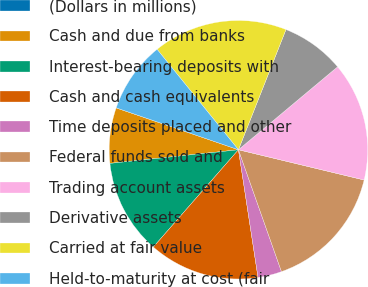Convert chart to OTSL. <chart><loc_0><loc_0><loc_500><loc_500><pie_chart><fcel>(Dollars in millions)<fcel>Cash and due from banks<fcel>Interest-bearing deposits with<fcel>Cash and cash equivalents<fcel>Time deposits placed and other<fcel>Federal funds sold and<fcel>Trading account assets<fcel>Derivative assets<fcel>Carried at fair value<fcel>Held-to-maturity at cost (fair<nl><fcel>0.01%<fcel>6.93%<fcel>11.88%<fcel>13.86%<fcel>2.98%<fcel>15.84%<fcel>14.85%<fcel>7.92%<fcel>16.83%<fcel>8.91%<nl></chart> 